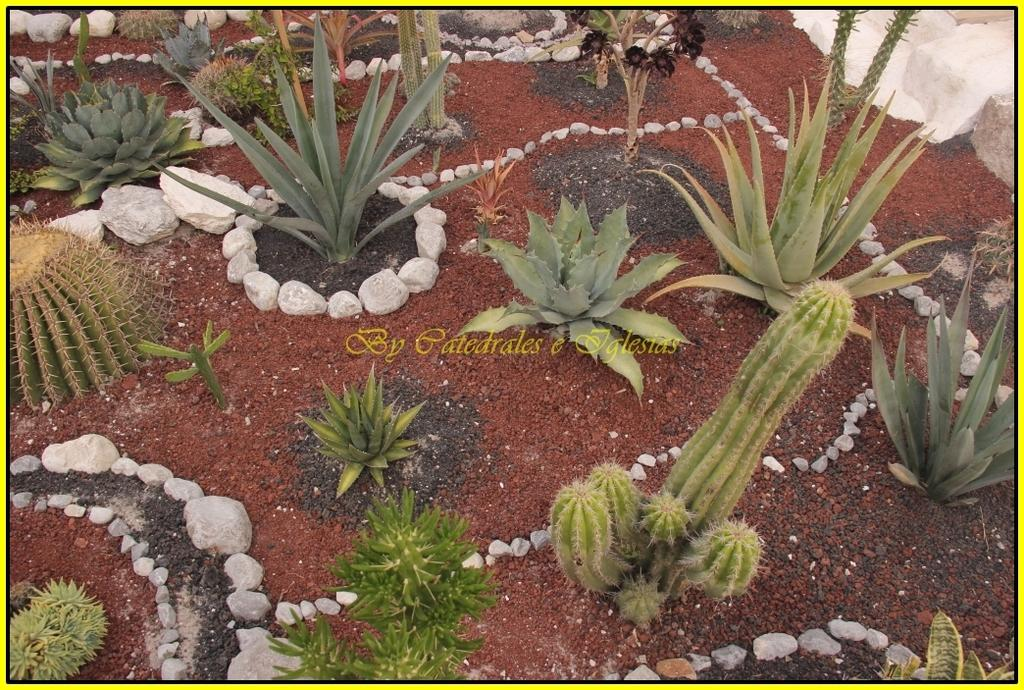What is located in the foreground of the image? There are plants in the foreground of the image. What is used to surround the plants in the image? White stones are used to surround the plants in the image. How are the white stones used in relation to the plants? Some white stones are used as a border for the plants. Can you tell me how many times the person in the image turns the notebook page? There is no person or notebook present in the image; it features plants and white stones. 